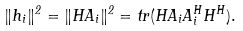Convert formula to latex. <formula><loc_0><loc_0><loc_500><loc_500>\| h _ { i } \| ^ { 2 } = \| H A _ { i } \| ^ { 2 } = t r ( H A _ { i } A _ { i } ^ { H } H ^ { H } ) .</formula> 